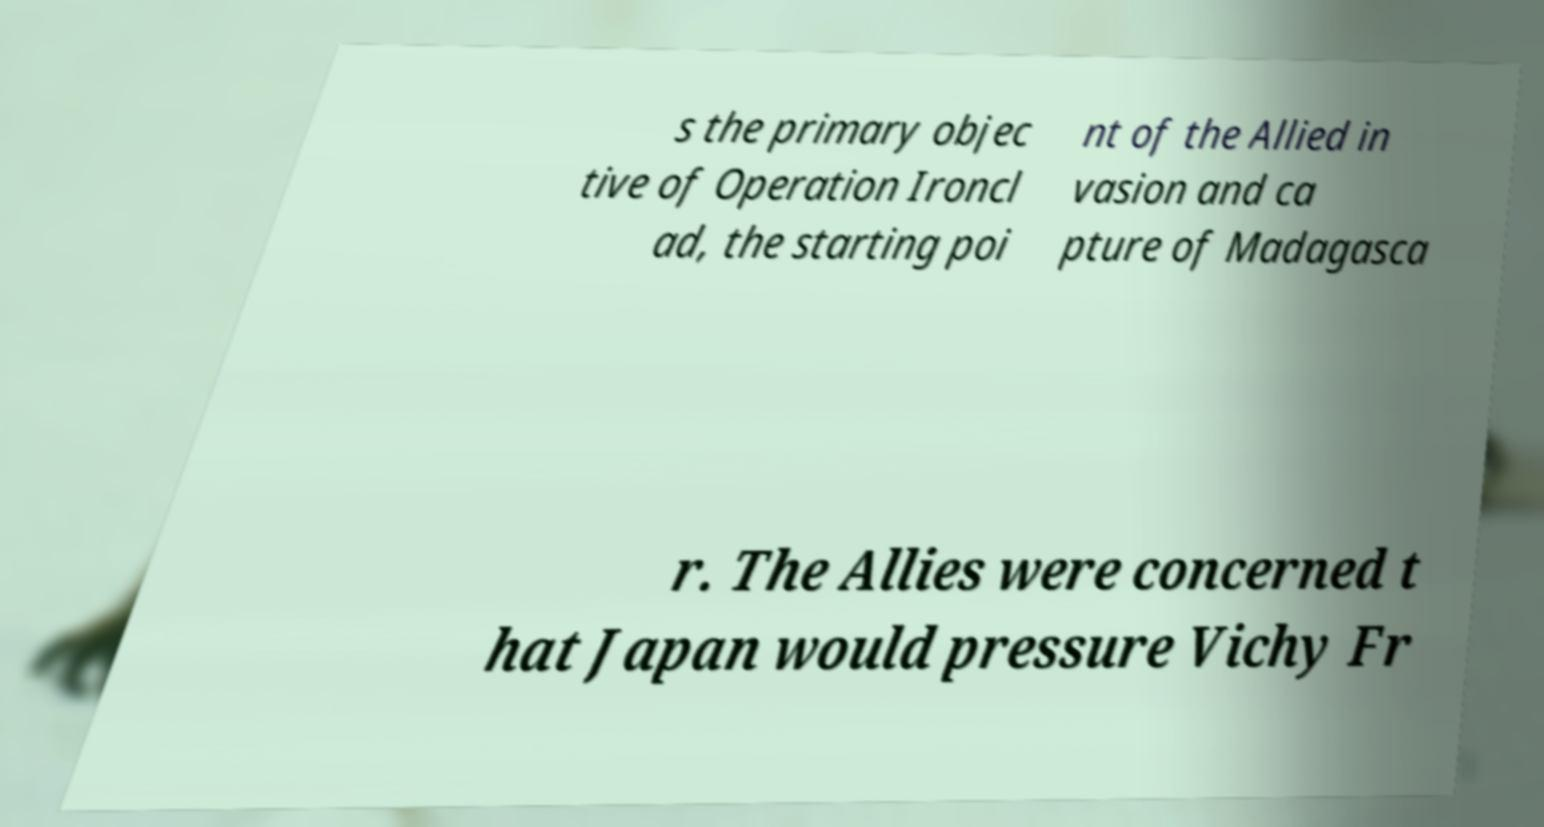What messages or text are displayed in this image? I need them in a readable, typed format. s the primary objec tive of Operation Ironcl ad, the starting poi nt of the Allied in vasion and ca pture of Madagasca r. The Allies were concerned t hat Japan would pressure Vichy Fr 